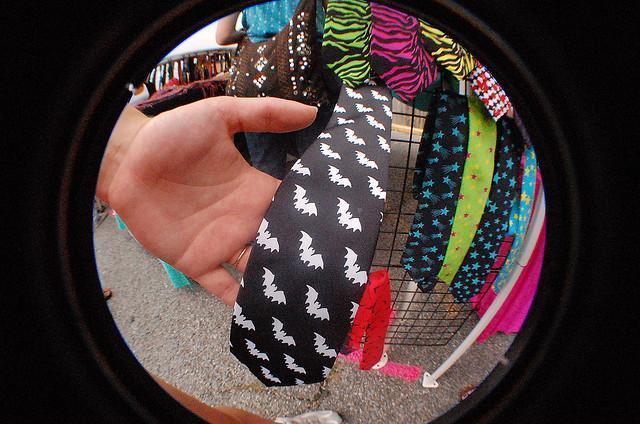How many people are there?
Give a very brief answer. 2. How many ties are there?
Give a very brief answer. 7. 